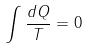<formula> <loc_0><loc_0><loc_500><loc_500>\int \frac { d Q } { T } = 0</formula> 